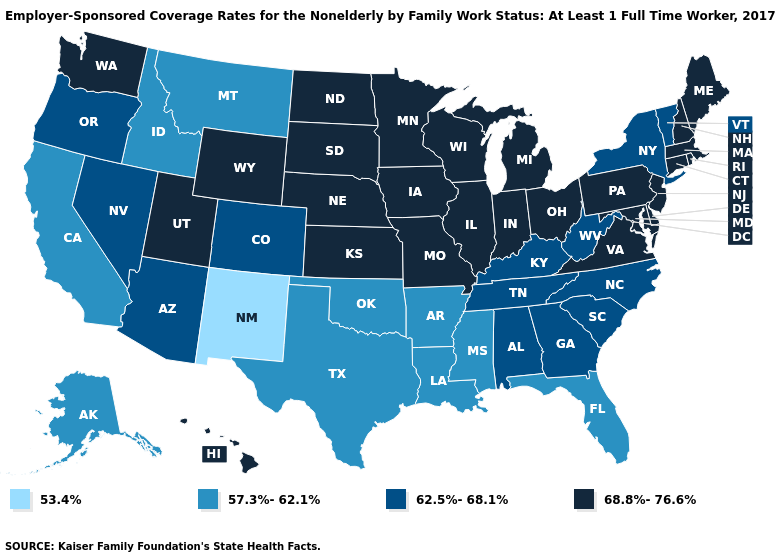What is the value of Vermont?
Quick response, please. 62.5%-68.1%. What is the highest value in the USA?
Short answer required. 68.8%-76.6%. Name the states that have a value in the range 57.3%-62.1%?
Be succinct. Alaska, Arkansas, California, Florida, Idaho, Louisiana, Mississippi, Montana, Oklahoma, Texas. Which states hav the highest value in the South?
Short answer required. Delaware, Maryland, Virginia. Name the states that have a value in the range 53.4%?
Short answer required. New Mexico. What is the value of Indiana?
Write a very short answer. 68.8%-76.6%. Name the states that have a value in the range 68.8%-76.6%?
Be succinct. Connecticut, Delaware, Hawaii, Illinois, Indiana, Iowa, Kansas, Maine, Maryland, Massachusetts, Michigan, Minnesota, Missouri, Nebraska, New Hampshire, New Jersey, North Dakota, Ohio, Pennsylvania, Rhode Island, South Dakota, Utah, Virginia, Washington, Wisconsin, Wyoming. Name the states that have a value in the range 62.5%-68.1%?
Concise answer only. Alabama, Arizona, Colorado, Georgia, Kentucky, Nevada, New York, North Carolina, Oregon, South Carolina, Tennessee, Vermont, West Virginia. Is the legend a continuous bar?
Answer briefly. No. Name the states that have a value in the range 62.5%-68.1%?
Be succinct. Alabama, Arizona, Colorado, Georgia, Kentucky, Nevada, New York, North Carolina, Oregon, South Carolina, Tennessee, Vermont, West Virginia. What is the highest value in the USA?
Answer briefly. 68.8%-76.6%. What is the highest value in the USA?
Concise answer only. 68.8%-76.6%. What is the lowest value in the South?
Keep it brief. 57.3%-62.1%. Which states have the highest value in the USA?
Answer briefly. Connecticut, Delaware, Hawaii, Illinois, Indiana, Iowa, Kansas, Maine, Maryland, Massachusetts, Michigan, Minnesota, Missouri, Nebraska, New Hampshire, New Jersey, North Dakota, Ohio, Pennsylvania, Rhode Island, South Dakota, Utah, Virginia, Washington, Wisconsin, Wyoming. 